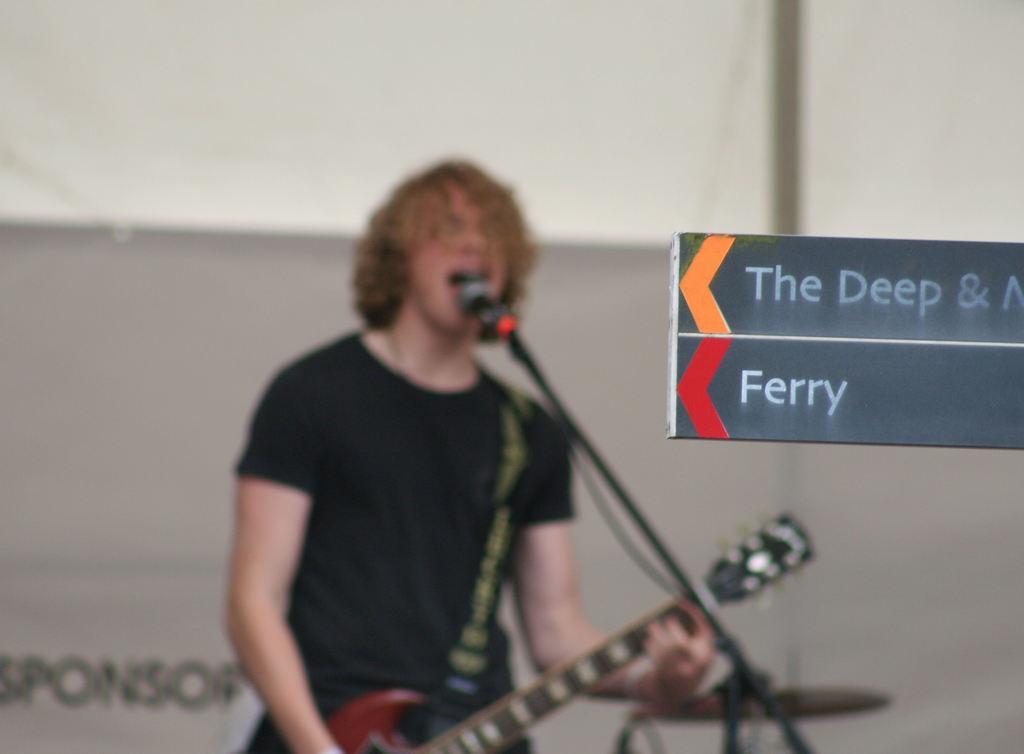Could you give a brief overview of what you see in this image? On the right side of the image, we can see name boards. Background we can see blur view. Here a person is holding a guitar and singing in-front of a microphone. Here there is a rod, wire and banner. Here there is a pole. 